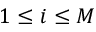<formula> <loc_0><loc_0><loc_500><loc_500>1 \leq i \leq M</formula> 